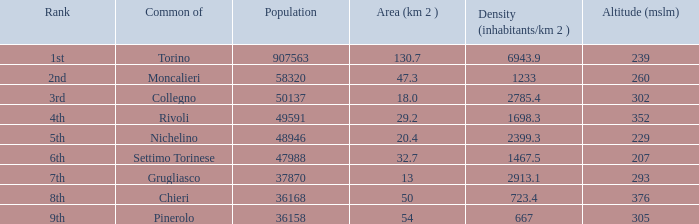How many altitudes does the common with an area of 130.7 km^2 have? 1.0. 